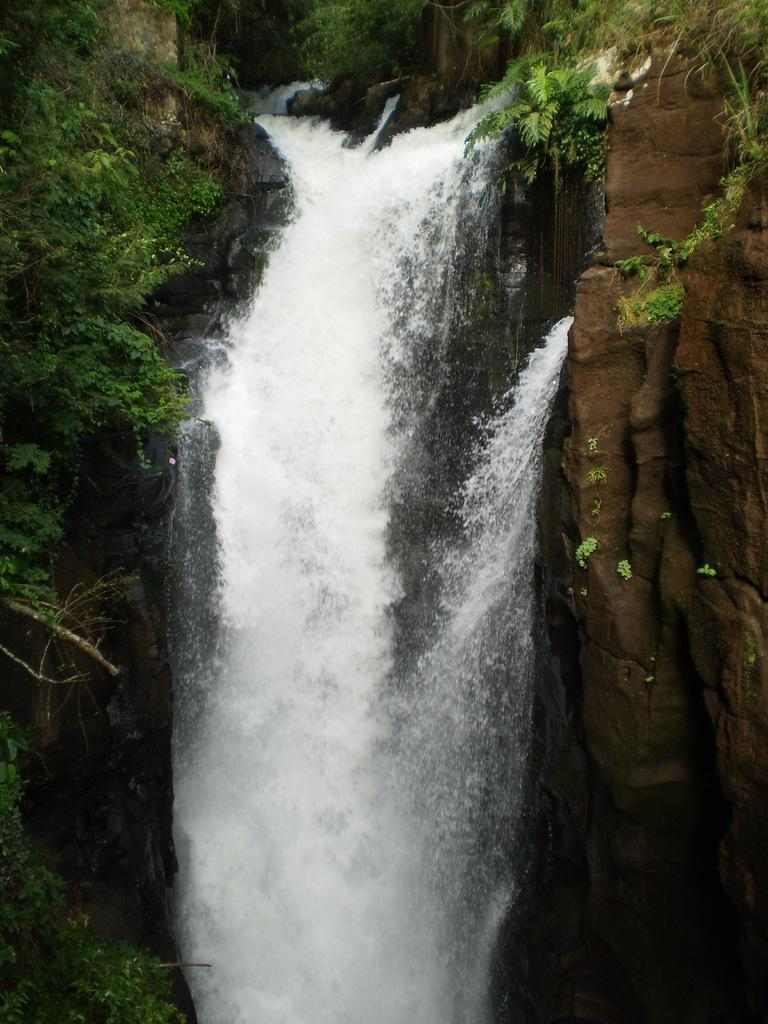What natural feature is the main subject of the image? There is a waterfall in the image. What type of vegetation can be seen in the image? There are trees in the image. What geological feature is present in the image? There is a rock in the image. What type of lettuce is growing in the yard in the image? There is no yard or lettuce present in the image; it features a waterfall, trees, and a rock. 